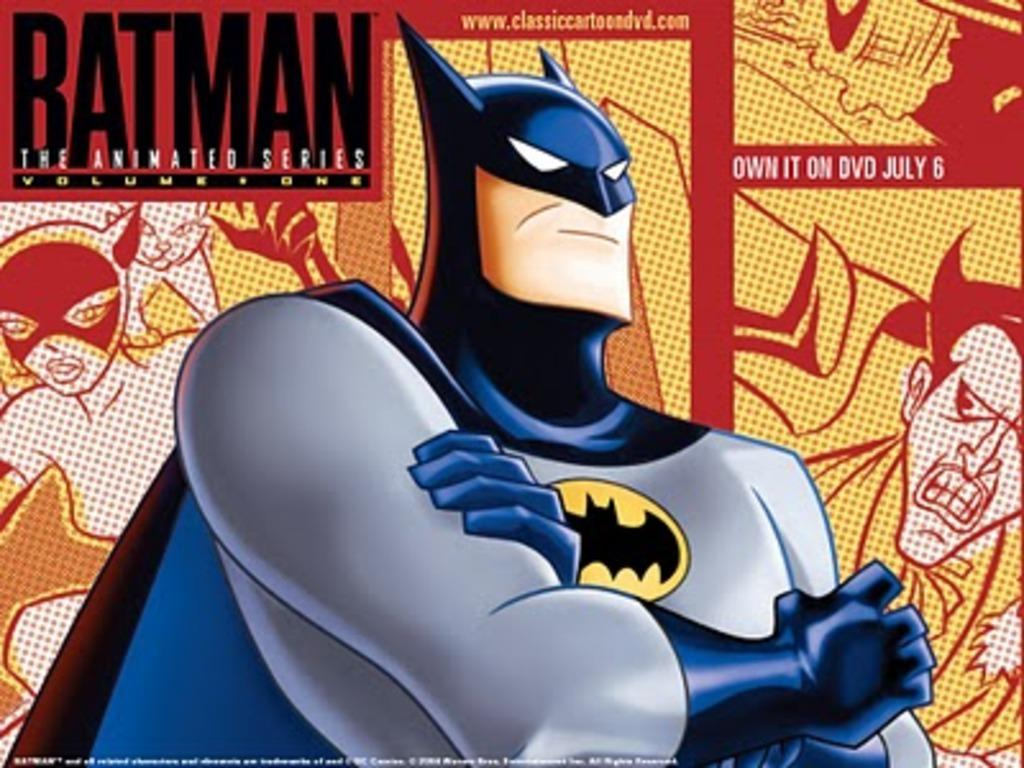What is the main subject of the image? There is an animation image of a batman in the image. What else can be seen in the background of the image? There are other pictures and names present in the background of the image. How many jelly containers can be seen in the image? There are no jelly containers present in the image. What type of men are depicted in the image? There is no depiction of men in the image; it features an animation image of a batman and other pictures in the background. 